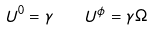<formula> <loc_0><loc_0><loc_500><loc_500>U ^ { 0 } = \gamma \quad U ^ { \phi } = \gamma \Omega</formula> 